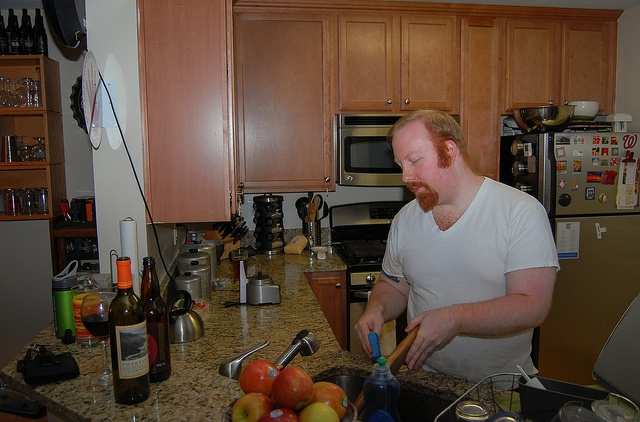Describe the objects in this image and their specific colors. I can see people in black, darkgray, gray, brown, and maroon tones, refrigerator in black, gray, and darkgreen tones, oven in black and gray tones, bottle in black, gray, and brown tones, and sink in black, gray, maroon, and darkgreen tones in this image. 